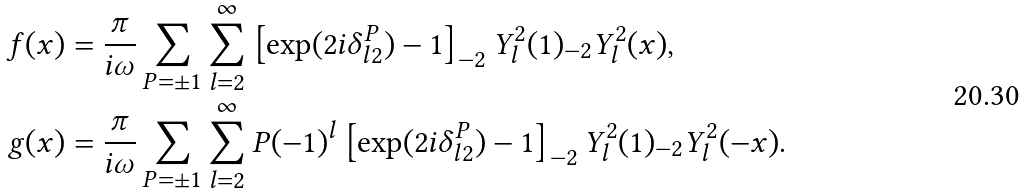Convert formula to latex. <formula><loc_0><loc_0><loc_500><loc_500>f ( x ) & = \frac { \pi } { i \omega } \sum _ { P = \pm 1 } \sum _ { l = 2 } ^ { \infty } \left [ \exp ( 2 i \delta _ { l 2 } ^ { P } ) - 1 \right ] _ { - 2 } Y _ { l } ^ { 2 } ( 1 ) _ { - 2 } Y _ { l } ^ { 2 } ( x ) , \\ g ( x ) & = \frac { \pi } { i \omega } \sum _ { P = \pm 1 } \sum _ { l = 2 } ^ { \infty } P ( - 1 ) ^ { l } \left [ \exp ( 2 i \delta _ { l 2 } ^ { P } ) - 1 \right ] _ { - 2 } Y _ { l } ^ { 2 } ( 1 ) _ { - 2 } Y _ { l } ^ { 2 } ( - x ) .</formula> 